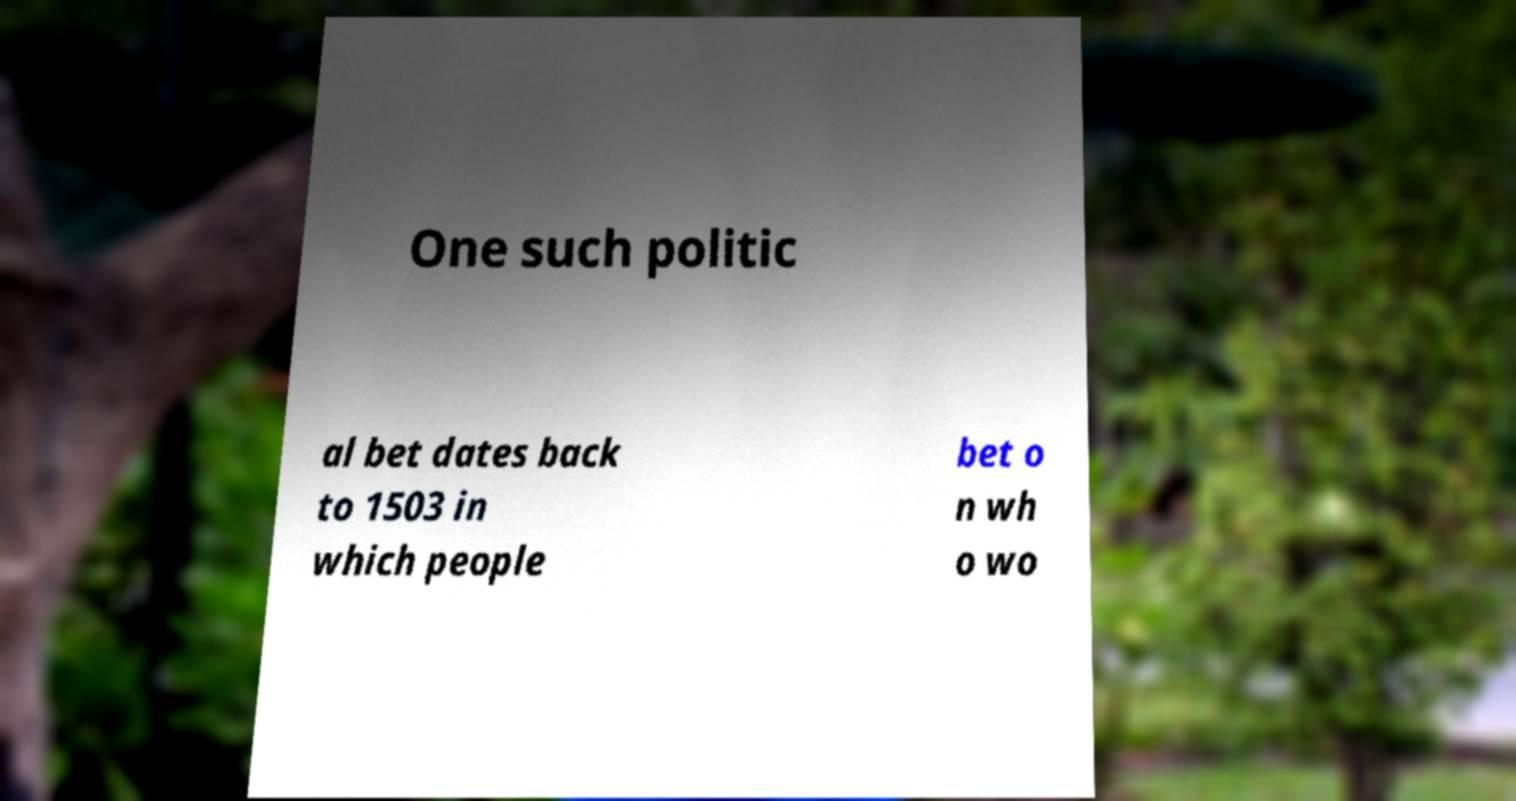For documentation purposes, I need the text within this image transcribed. Could you provide that? One such politic al bet dates back to 1503 in which people bet o n wh o wo 